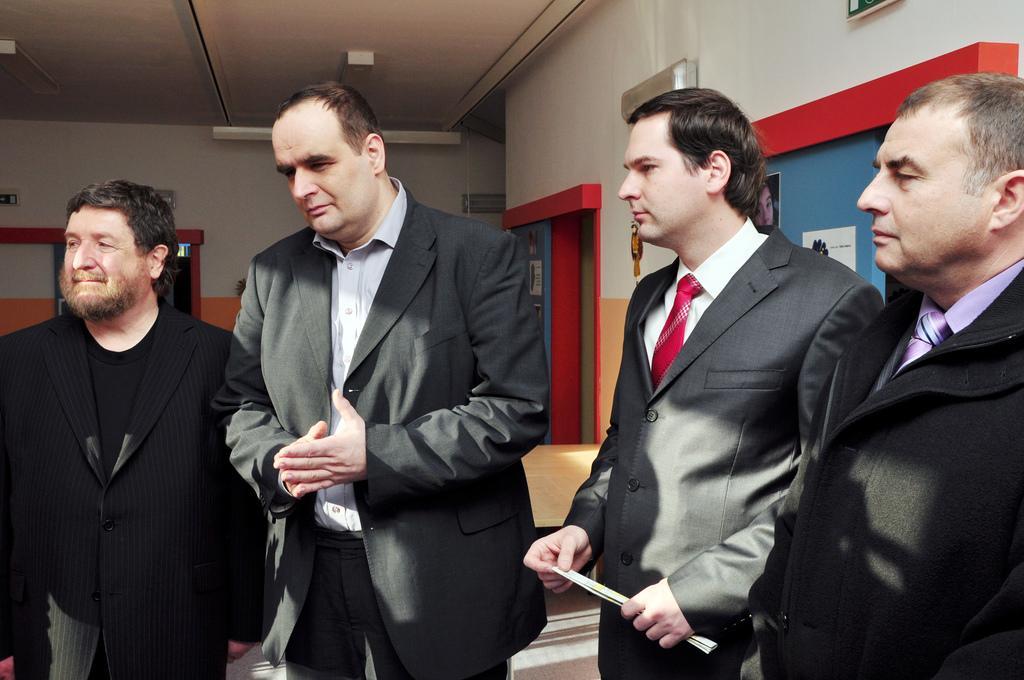Please provide a concise description of this image. In this picture I can see four persons standing, there are posters attached to the walls, there are boards, lights and some other objects. 